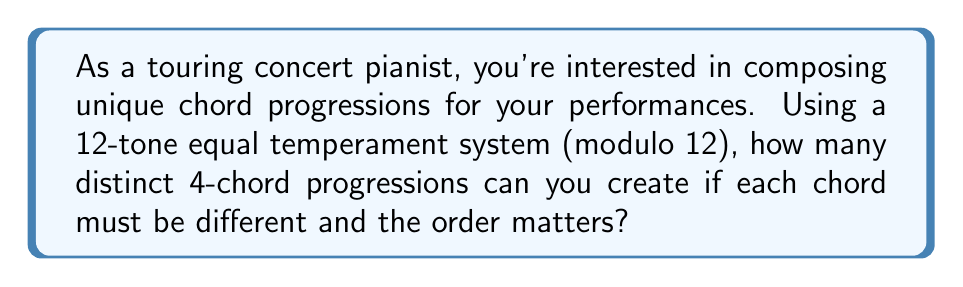Can you solve this math problem? Let's approach this step-by-step using modular arithmetic and permutation principles:

1) In the 12-tone equal temperament system, we can represent each note as an integer from 0 to 11 (mod 12). For example:
   C = 0, C# = 1, D = 2, ..., B = 11

2) We need to select 4 chords out of 12 possible chords, where the order matters and repetition is not allowed. This is a permutation problem.

3) The number of ways to select 4 chords out of 12, where order matters and without repetition, is given by the permutation formula:

   $$P(12,4) = \frac{12!}{(12-4)!} = \frac{12!}{8!}$$

4) Let's calculate this:
   $$\frac{12!}{8!} = 12 \times 11 \times 10 \times 9 = 11880$$

5) Therefore, there are 11,880 possible 4-chord progressions where each chord is different and the order matters.

Note: This calculation assumes that we're only considering the root of each chord. If we were to consider different chord types (major, minor, diminished, etc.) for each root, the number of possibilities would be much larger.
Answer: 11,880 distinct 4-chord progressions 